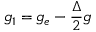Convert formula to latex. <formula><loc_0><loc_0><loc_500><loc_500>g _ { 1 } = g _ { e } - \frac { \Delta } { 2 } g</formula> 